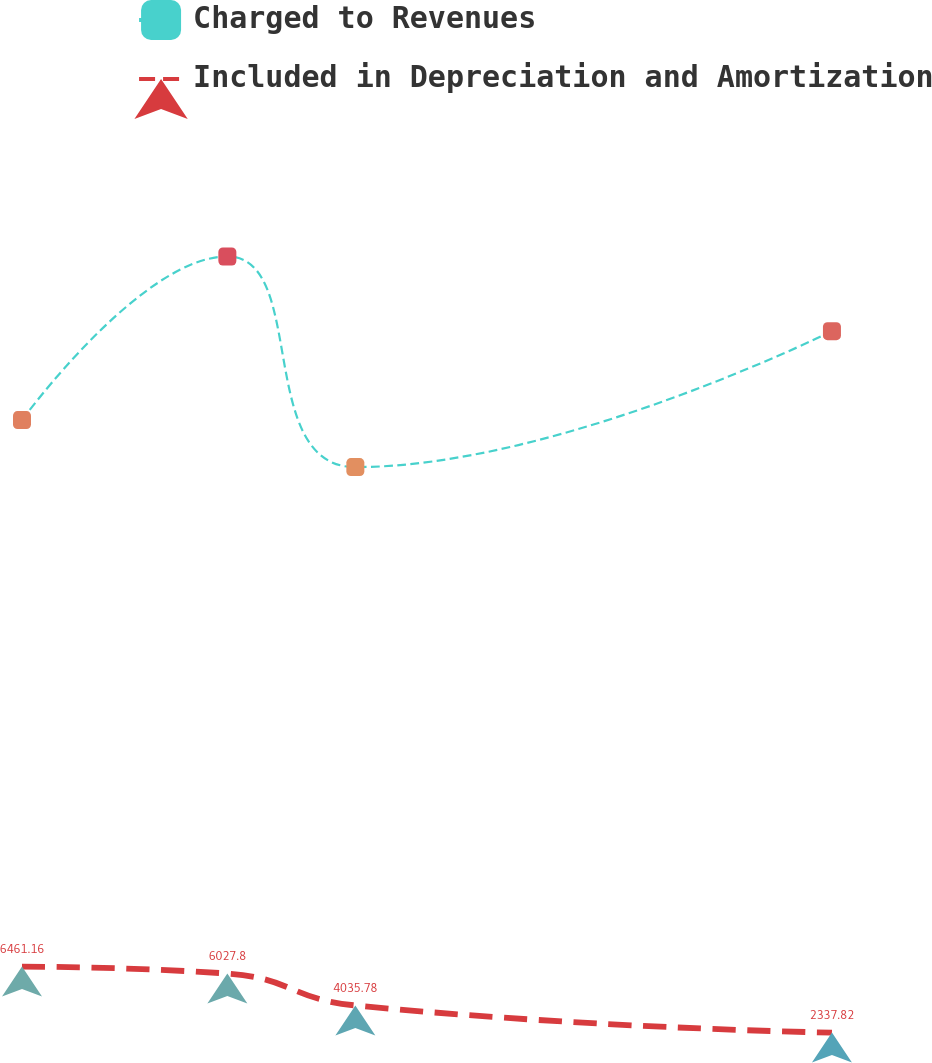Convert chart. <chart><loc_0><loc_0><loc_500><loc_500><line_chart><ecel><fcel>Charged to Revenues<fcel>Included in Depreciation and Amortization<nl><fcel>1628.62<fcel>40617.5<fcel>6461.16<nl><fcel>1750.97<fcel>50846.6<fcel>6027.8<nl><fcel>1827.23<fcel>37680.8<fcel>4035.78<nl><fcel>2111.19<fcel>46177.3<fcel>2337.82<nl><fcel>2391.25<fcel>47895.2<fcel>1729.62<nl></chart> 